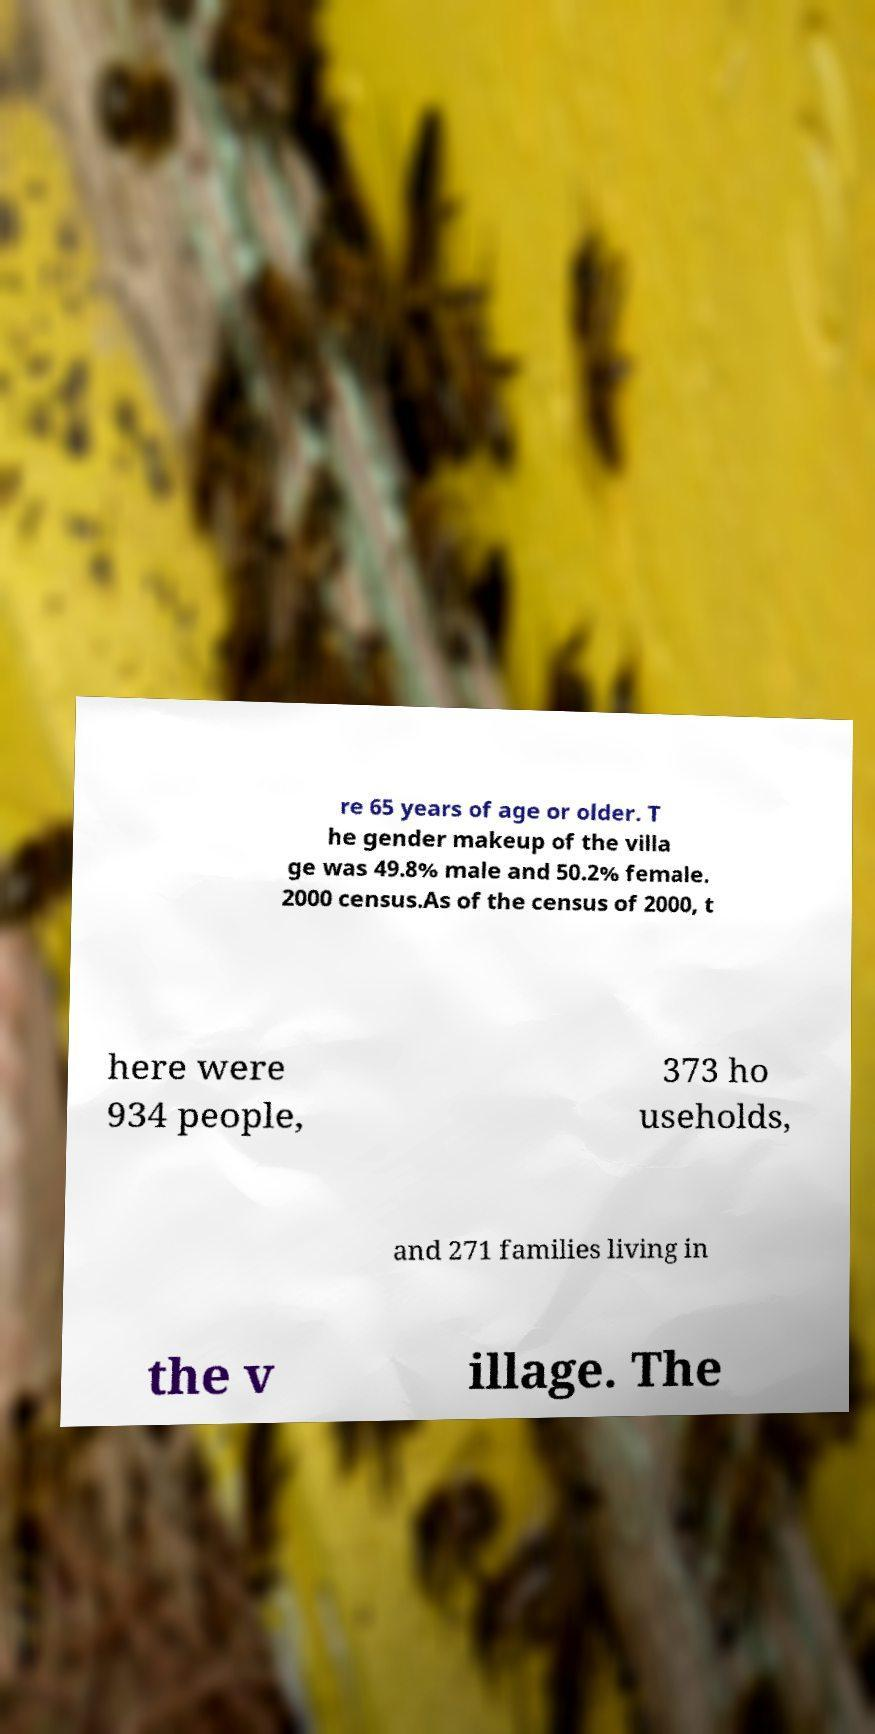Please identify and transcribe the text found in this image. re 65 years of age or older. T he gender makeup of the villa ge was 49.8% male and 50.2% female. 2000 census.As of the census of 2000, t here were 934 people, 373 ho useholds, and 271 families living in the v illage. The 